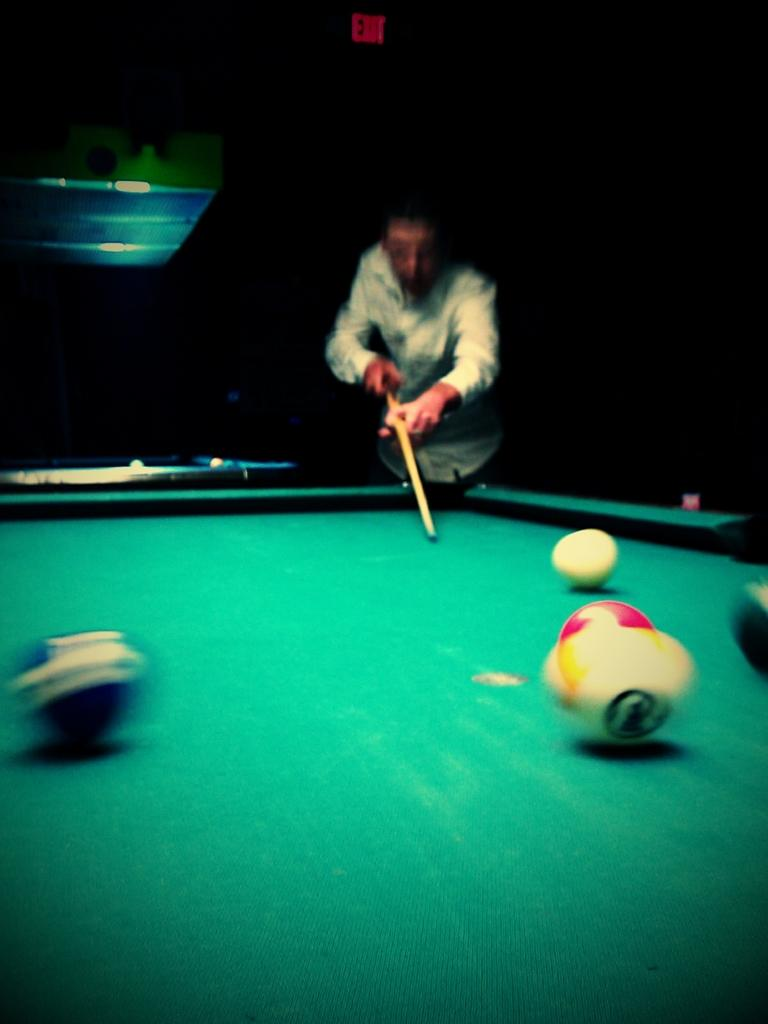What is the main subject of the image? There is a man in the image. What activity is the man engaged in? The man is playing snooker. What type of plant can be seen growing in the image? There is no plant visible in the image; it features a man playing snooker. How many minutes does it take for the man to complete a game of snooker in the image? The image does not provide information about the duration of the game, nor does it show the entire game being played. 